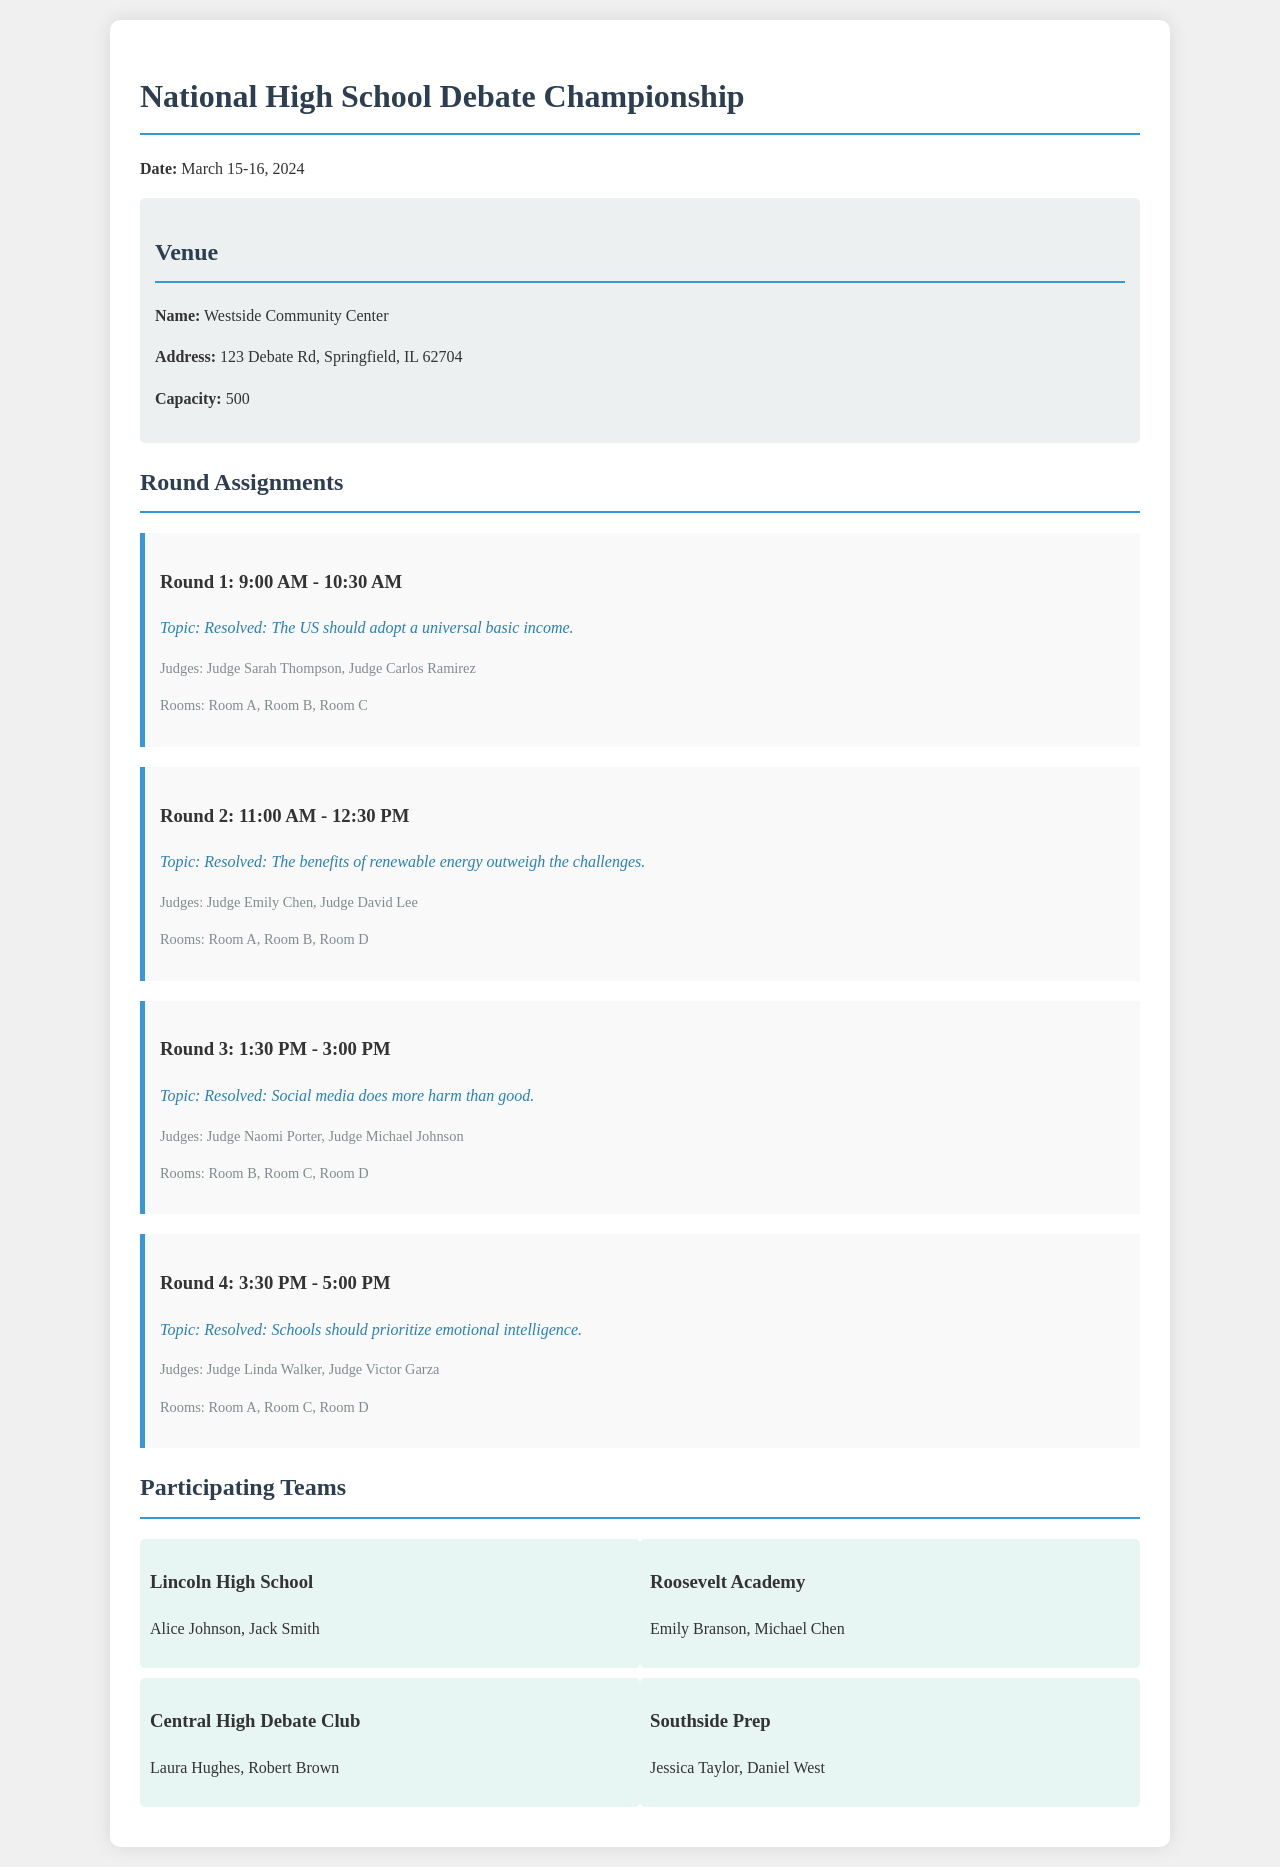What is the date of the championship? The date of the championship is explicitly mentioned in the document.
Answer: March 15-16, 2024 What is the venue name? The venue name is provided in the venue information section.
Answer: Westside Community Center How many judges are assigned to Round 2? The document states the judges for each round, and Round 2 has two judges listed.
Answer: 2 What is the topic for Round 3? The topic for Round 3 is detailed in the round section for that round.
Answer: Resolved: Social media does more harm than good Which teams are participating from Lincoln High School? The participants from Lincoln High School are listed within their team section.
Answer: Alice Johnson, Jack Smith How many rooms are used in Round 1? Room details are mentioned for each round, and Round 1 lists three rooms.
Answer: 3 What time does Round 4 start? The start time for each round is given, and Round 4 starts at a specific time.
Answer: 3:30 PM Which team has participants named Jessica Taylor and Daniel West? The team names are matched to their participants from the participants section.
Answer: Southside Prep What is the capacity of the venue? The capacity is explicitly mentioned under the venue information.
Answer: 500 